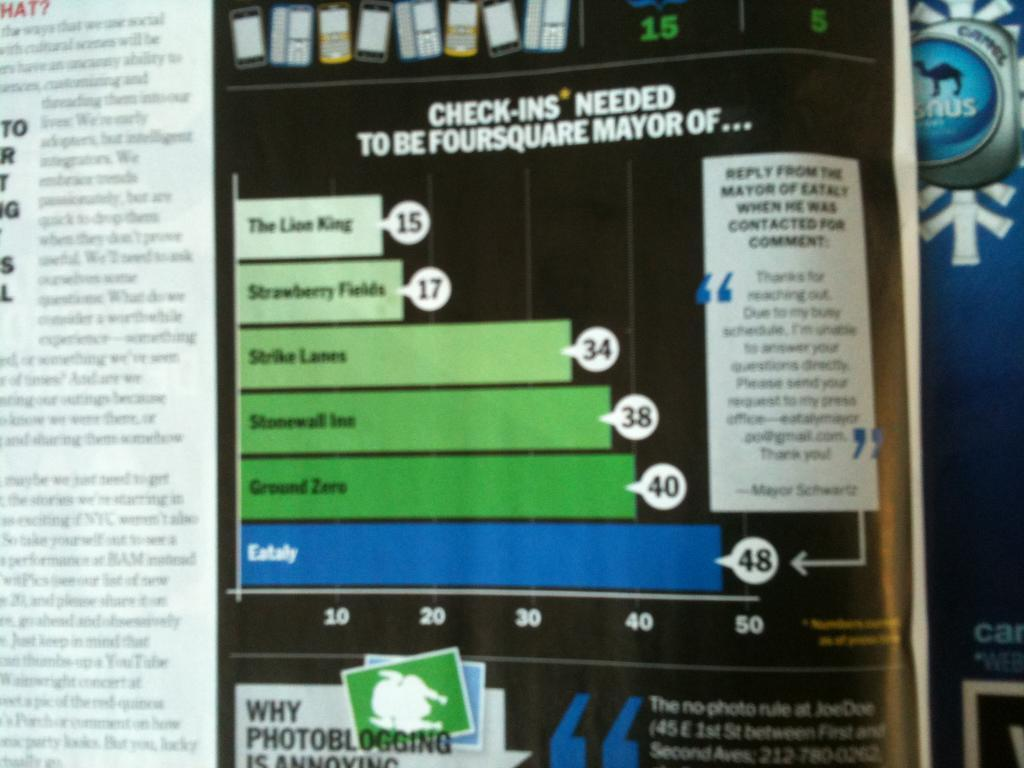<image>
Describe the image concisely. Magazine that includes check ins needed to be foursquare mayor of 